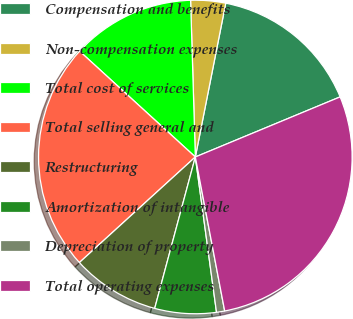Convert chart. <chart><loc_0><loc_0><loc_500><loc_500><pie_chart><fcel>Compensation and benefits<fcel>Non-compensation expenses<fcel>Total cost of services<fcel>Total selling general and<fcel>Restructuring<fcel>Amortization of intangible<fcel>Depreciation of property<fcel>Total operating expenses<nl><fcel>15.63%<fcel>3.59%<fcel>12.73%<fcel>23.54%<fcel>9.07%<fcel>6.33%<fcel>0.84%<fcel>28.26%<nl></chart> 